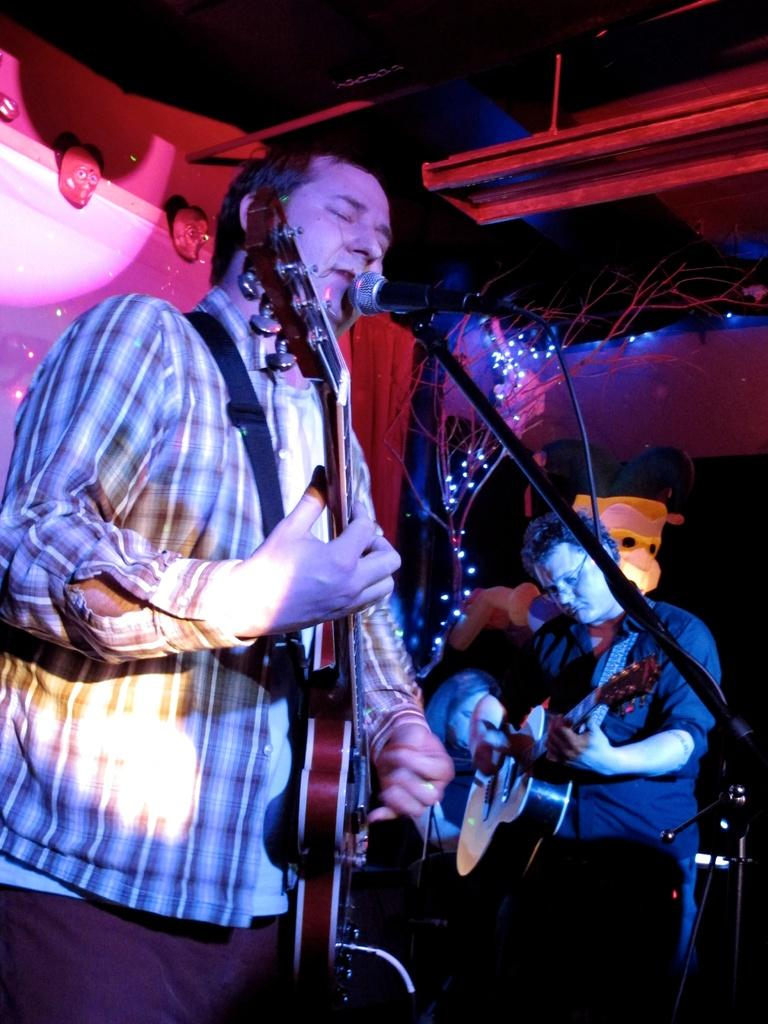What is the main activity of the person in the image? The person in the image is playing a guitar. What else is the person doing while playing the guitar? The person is singing a song. How is the person's voice being amplified in the image? The person is using a microphone. Are there any other musicians in the image? Yes, there is another person playing a guitar beside the first person. What type of property is being sold in the image? There is no property being sold in the image; it features a person playing a guitar and another person playing a guitar beside them. How many oranges are visible in the image? There are there any oranges present in the image? 